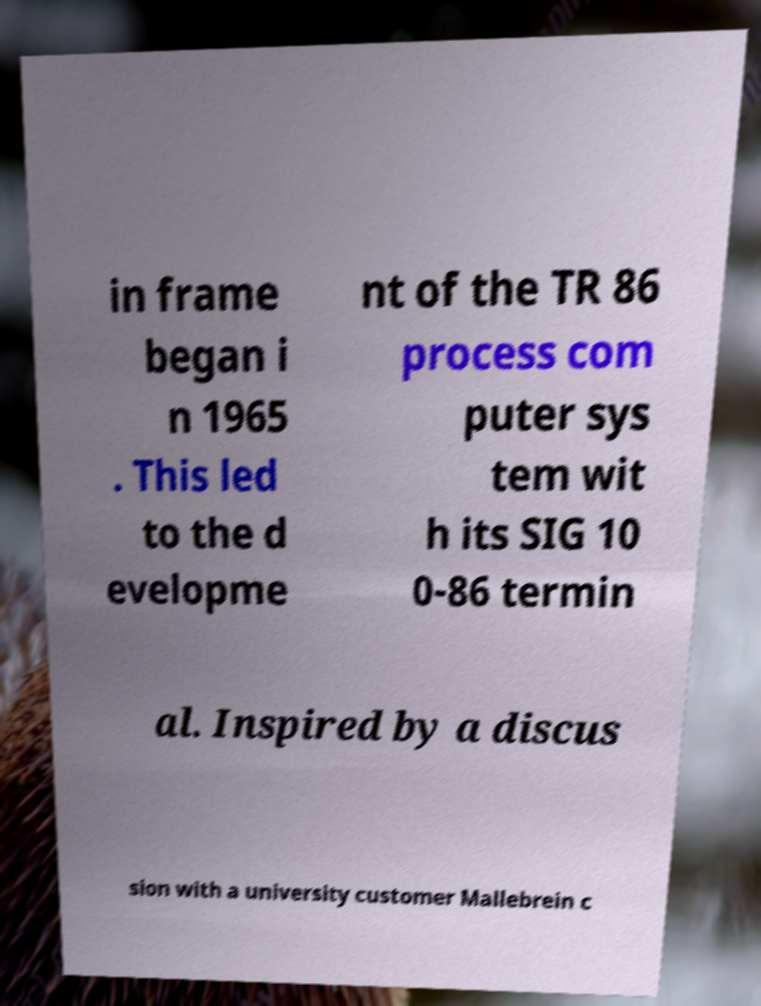I need the written content from this picture converted into text. Can you do that? in frame began i n 1965 . This led to the d evelopme nt of the TR 86 process com puter sys tem wit h its SIG 10 0-86 termin al. Inspired by a discus sion with a university customer Mallebrein c 